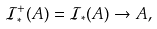Convert formula to latex. <formula><loc_0><loc_0><loc_500><loc_500>\mathcal { I } _ { * } ^ { + } ( A ) = \mathcal { I } _ { * } ( A ) \rightarrow A ,</formula> 